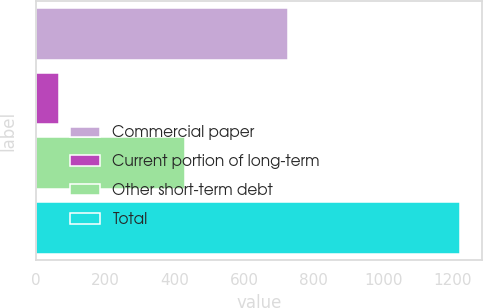Convert chart. <chart><loc_0><loc_0><loc_500><loc_500><bar_chart><fcel>Commercial paper<fcel>Current portion of long-term<fcel>Other short-term debt<fcel>Total<nl><fcel>726.5<fcel>67.2<fcel>428.8<fcel>1222.5<nl></chart> 